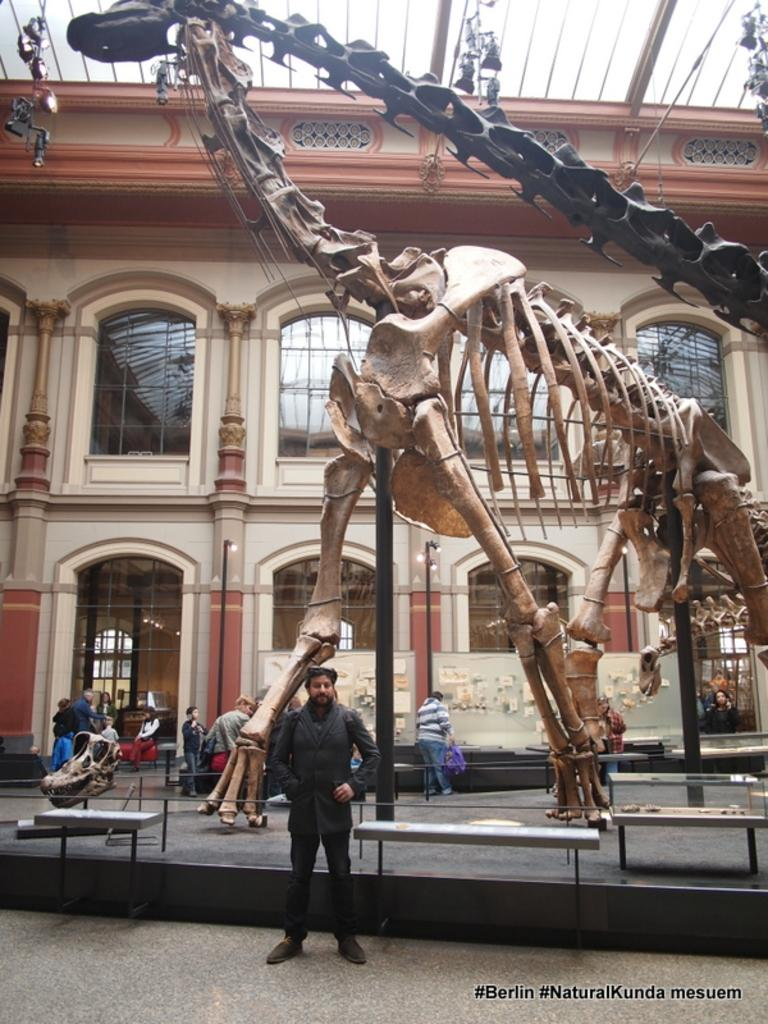What type of structure is in the image? There is a building in the image. What are the poles used for in the image? The poles are likely used to support the lights in the image. Can you describe the lights in the image? Yes, there are lights in the image. What type of furniture is present in the image? Tables are present in the image. What unusual object can be seen in the image? A skeleton is visible in the image. How many people are in the image? There are people in the image. What is the watermark at the bottom of the image? There is a watermark at the bottom of the image. What type of ink is used to draw the operation level in the image? There is no ink, operation, or level present in the image. 